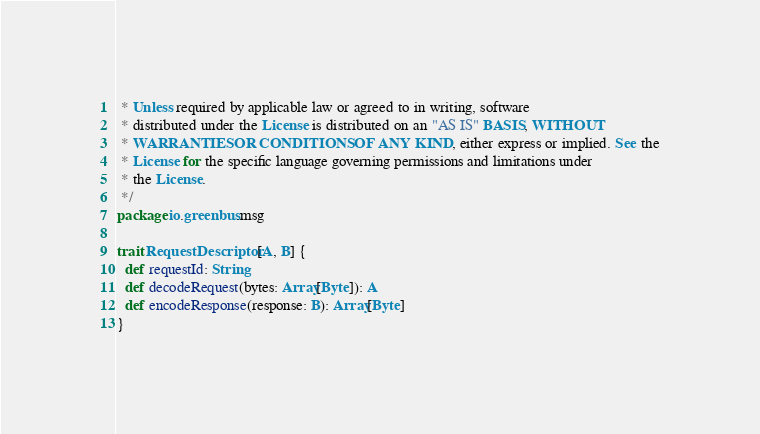Convert code to text. <code><loc_0><loc_0><loc_500><loc_500><_Scala_> * Unless required by applicable law or agreed to in writing, software
 * distributed under the License is distributed on an "AS IS" BASIS, WITHOUT
 * WARRANTIES OR CONDITIONS OF ANY KIND, either express or implied. See the
 * License for the specific language governing permissions and limitations under
 * the License.
 */
package io.greenbus.msg

trait RequestDescriptor[A, B] {
  def requestId: String
  def decodeRequest(bytes: Array[Byte]): A
  def encodeResponse(response: B): Array[Byte]
}

</code> 